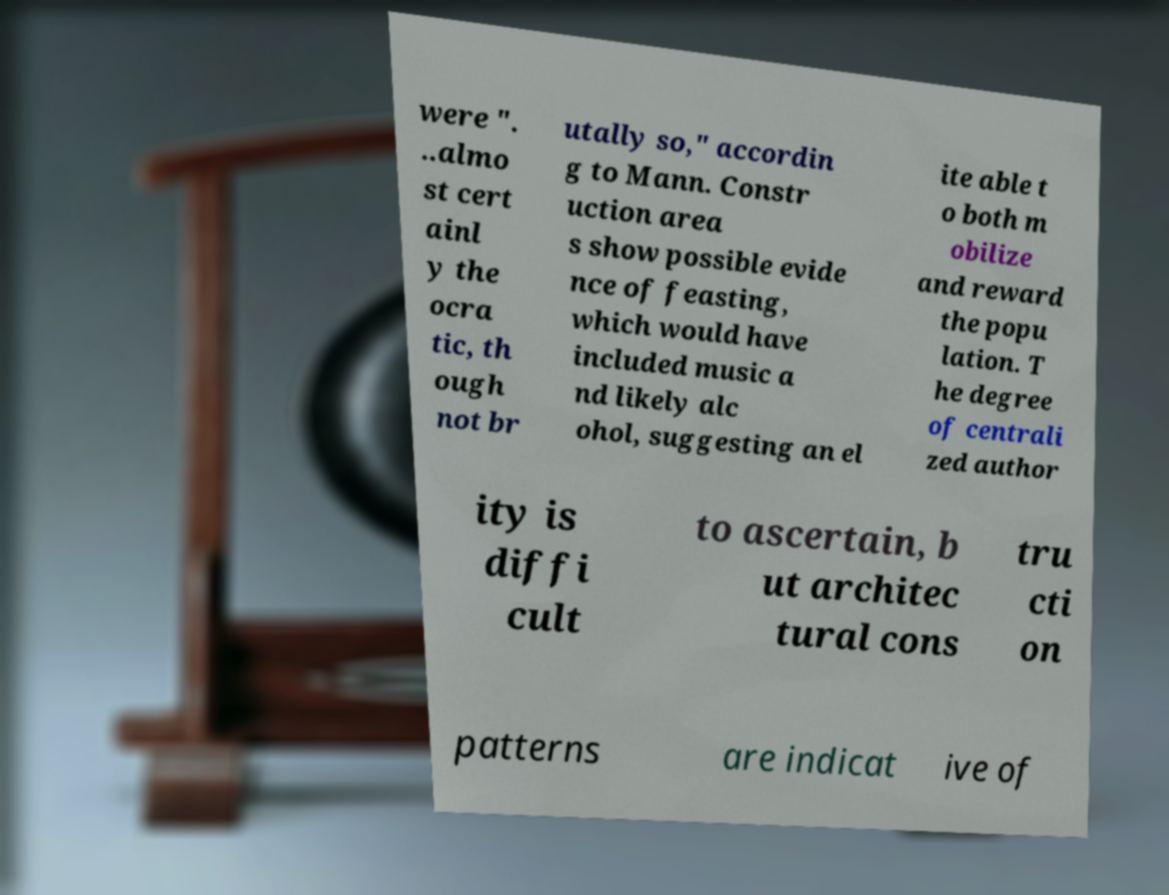Could you extract and type out the text from this image? were ". ..almo st cert ainl y the ocra tic, th ough not br utally so," accordin g to Mann. Constr uction area s show possible evide nce of feasting, which would have included music a nd likely alc ohol, suggesting an el ite able t o both m obilize and reward the popu lation. T he degree of centrali zed author ity is diffi cult to ascertain, b ut architec tural cons tru cti on patterns are indicat ive of 